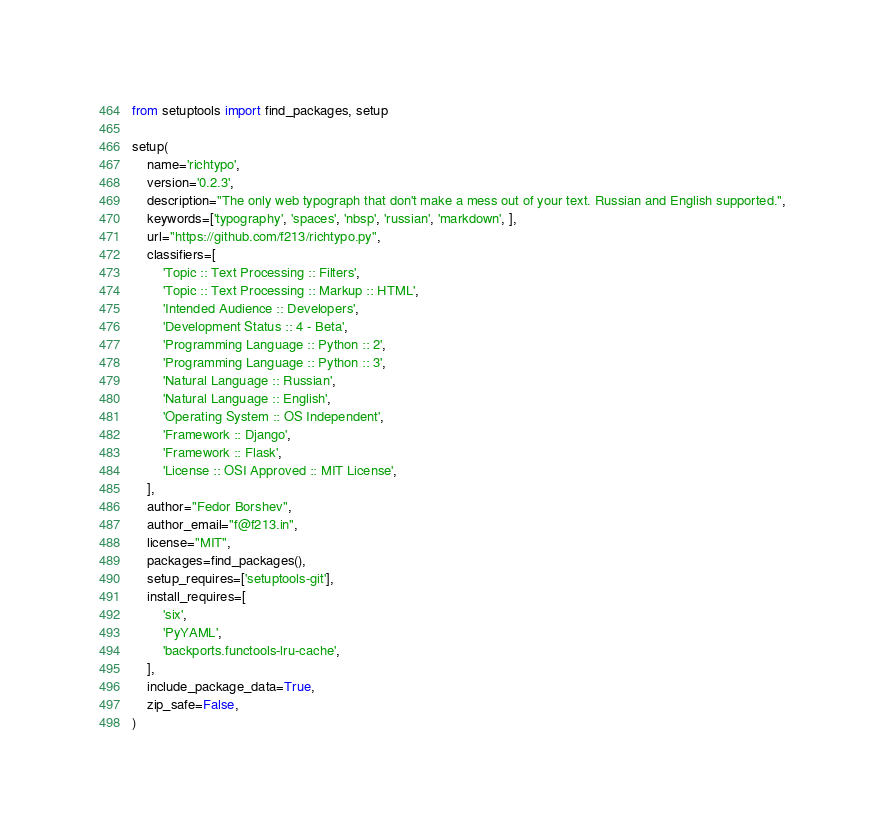Convert code to text. <code><loc_0><loc_0><loc_500><loc_500><_Python_>from setuptools import find_packages, setup

setup(
    name='richtypo',
    version='0.2.3',
    description="The only web typograph that don't make a mess out of your text. Russian and English supported.",
    keywords=['typography', 'spaces', 'nbsp', 'russian', 'markdown', ],
    url="https://github.com/f213/richtypo.py",
    classifiers=[
        'Topic :: Text Processing :: Filters',
        'Topic :: Text Processing :: Markup :: HTML',
        'Intended Audience :: Developers',
        'Development Status :: 4 - Beta',
        'Programming Language :: Python :: 2',
        'Programming Language :: Python :: 3',
        'Natural Language :: Russian',
        'Natural Language :: English',
        'Operating System :: OS Independent',
        'Framework :: Django',
        'Framework :: Flask',
        'License :: OSI Approved :: MIT License',
    ],
    author="Fedor Borshev",
    author_email="f@f213.in",
    license="MIT",
    packages=find_packages(),
    setup_requires=['setuptools-git'],
    install_requires=[
        'six',
        'PyYAML',
        'backports.functools-lru-cache',
    ],
    include_package_data=True,
    zip_safe=False,
)
</code> 